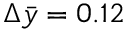Convert formula to latex. <formula><loc_0><loc_0><loc_500><loc_500>\Delta \bar { y } = 0 . 1 2</formula> 